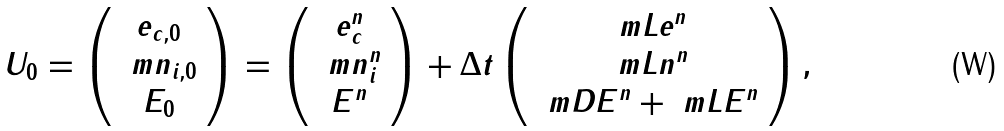Convert formula to latex. <formula><loc_0><loc_0><loc_500><loc_500>U _ { 0 } = \left ( \begin{array} { c } e _ { c , 0 } \\ \ m n _ { i , 0 } \\ E _ { 0 } \end{array} \right ) = \left ( \begin{array} { c } e _ { c } ^ { n } \\ \ m n _ { i } ^ { n } \\ E ^ { n } \end{array} \right ) + \Delta t \left ( \begin{array} { c } \ m L e ^ { n } \\ \ m L n ^ { n } \\ \ m D E ^ { n } + \ m L E ^ { n } \end{array} \right ) ,</formula> 